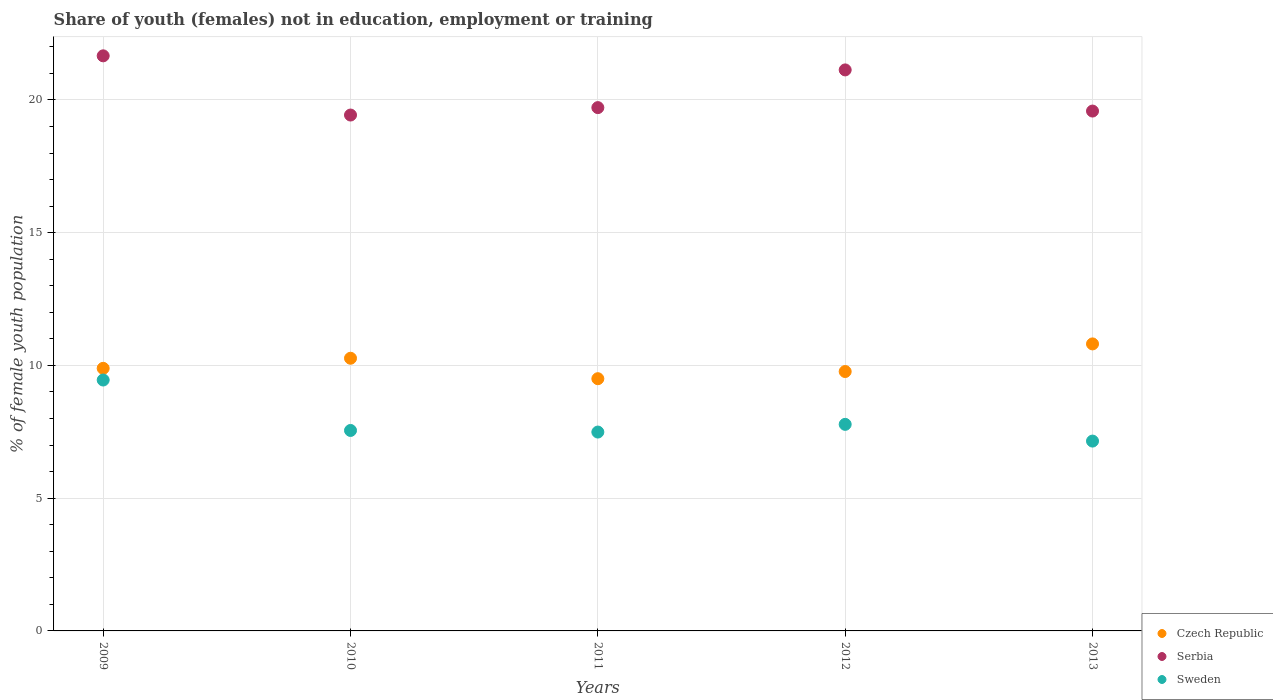What is the percentage of unemployed female population in in Czech Republic in 2009?
Provide a short and direct response. 9.89. Across all years, what is the maximum percentage of unemployed female population in in Serbia?
Make the answer very short. 21.66. Across all years, what is the minimum percentage of unemployed female population in in Czech Republic?
Provide a succinct answer. 9.5. What is the total percentage of unemployed female population in in Czech Republic in the graph?
Your response must be concise. 50.24. What is the difference between the percentage of unemployed female population in in Czech Republic in 2011 and that in 2013?
Offer a very short reply. -1.31. What is the difference between the percentage of unemployed female population in in Serbia in 2013 and the percentage of unemployed female population in in Czech Republic in 2012?
Your response must be concise. 9.81. What is the average percentage of unemployed female population in in Serbia per year?
Make the answer very short. 20.3. In the year 2009, what is the difference between the percentage of unemployed female population in in Serbia and percentage of unemployed female population in in Sweden?
Offer a terse response. 12.21. In how many years, is the percentage of unemployed female population in in Serbia greater than 1 %?
Ensure brevity in your answer.  5. What is the ratio of the percentage of unemployed female population in in Serbia in 2009 to that in 2011?
Ensure brevity in your answer.  1.1. What is the difference between the highest and the second highest percentage of unemployed female population in in Sweden?
Provide a short and direct response. 1.67. What is the difference between the highest and the lowest percentage of unemployed female population in in Serbia?
Keep it short and to the point. 2.23. In how many years, is the percentage of unemployed female population in in Czech Republic greater than the average percentage of unemployed female population in in Czech Republic taken over all years?
Your answer should be very brief. 2. Is the sum of the percentage of unemployed female population in in Czech Republic in 2009 and 2013 greater than the maximum percentage of unemployed female population in in Sweden across all years?
Make the answer very short. Yes. Is it the case that in every year, the sum of the percentage of unemployed female population in in Sweden and percentage of unemployed female population in in Czech Republic  is greater than the percentage of unemployed female population in in Serbia?
Your answer should be very brief. No. Does the percentage of unemployed female population in in Serbia monotonically increase over the years?
Give a very brief answer. No. How many years are there in the graph?
Your response must be concise. 5. Does the graph contain any zero values?
Ensure brevity in your answer.  No. Does the graph contain grids?
Keep it short and to the point. Yes. How many legend labels are there?
Keep it short and to the point. 3. How are the legend labels stacked?
Your answer should be compact. Vertical. What is the title of the graph?
Offer a very short reply. Share of youth (females) not in education, employment or training. Does "Burundi" appear as one of the legend labels in the graph?
Your answer should be very brief. No. What is the label or title of the Y-axis?
Offer a terse response. % of female youth population. What is the % of female youth population of Czech Republic in 2009?
Your answer should be compact. 9.89. What is the % of female youth population in Serbia in 2009?
Ensure brevity in your answer.  21.66. What is the % of female youth population of Sweden in 2009?
Keep it short and to the point. 9.45. What is the % of female youth population of Czech Republic in 2010?
Keep it short and to the point. 10.27. What is the % of female youth population in Serbia in 2010?
Your response must be concise. 19.43. What is the % of female youth population of Sweden in 2010?
Keep it short and to the point. 7.55. What is the % of female youth population of Serbia in 2011?
Your answer should be compact. 19.71. What is the % of female youth population in Sweden in 2011?
Your answer should be compact. 7.49. What is the % of female youth population of Czech Republic in 2012?
Offer a terse response. 9.77. What is the % of female youth population in Serbia in 2012?
Provide a succinct answer. 21.13. What is the % of female youth population of Sweden in 2012?
Your answer should be compact. 7.78. What is the % of female youth population of Czech Republic in 2013?
Make the answer very short. 10.81. What is the % of female youth population of Serbia in 2013?
Ensure brevity in your answer.  19.58. What is the % of female youth population in Sweden in 2013?
Make the answer very short. 7.15. Across all years, what is the maximum % of female youth population of Czech Republic?
Offer a very short reply. 10.81. Across all years, what is the maximum % of female youth population of Serbia?
Offer a very short reply. 21.66. Across all years, what is the maximum % of female youth population in Sweden?
Provide a succinct answer. 9.45. Across all years, what is the minimum % of female youth population of Czech Republic?
Offer a terse response. 9.5. Across all years, what is the minimum % of female youth population of Serbia?
Provide a short and direct response. 19.43. Across all years, what is the minimum % of female youth population in Sweden?
Your answer should be very brief. 7.15. What is the total % of female youth population in Czech Republic in the graph?
Give a very brief answer. 50.24. What is the total % of female youth population of Serbia in the graph?
Keep it short and to the point. 101.51. What is the total % of female youth population of Sweden in the graph?
Your answer should be compact. 39.42. What is the difference between the % of female youth population of Czech Republic in 2009 and that in 2010?
Offer a terse response. -0.38. What is the difference between the % of female youth population in Serbia in 2009 and that in 2010?
Provide a succinct answer. 2.23. What is the difference between the % of female youth population in Sweden in 2009 and that in 2010?
Offer a very short reply. 1.9. What is the difference between the % of female youth population in Czech Republic in 2009 and that in 2011?
Give a very brief answer. 0.39. What is the difference between the % of female youth population in Serbia in 2009 and that in 2011?
Make the answer very short. 1.95. What is the difference between the % of female youth population of Sweden in 2009 and that in 2011?
Your answer should be very brief. 1.96. What is the difference between the % of female youth population in Czech Republic in 2009 and that in 2012?
Make the answer very short. 0.12. What is the difference between the % of female youth population of Serbia in 2009 and that in 2012?
Offer a terse response. 0.53. What is the difference between the % of female youth population of Sweden in 2009 and that in 2012?
Give a very brief answer. 1.67. What is the difference between the % of female youth population in Czech Republic in 2009 and that in 2013?
Keep it short and to the point. -0.92. What is the difference between the % of female youth population in Serbia in 2009 and that in 2013?
Offer a terse response. 2.08. What is the difference between the % of female youth population of Sweden in 2009 and that in 2013?
Your response must be concise. 2.3. What is the difference between the % of female youth population in Czech Republic in 2010 and that in 2011?
Ensure brevity in your answer.  0.77. What is the difference between the % of female youth population of Serbia in 2010 and that in 2011?
Provide a short and direct response. -0.28. What is the difference between the % of female youth population in Sweden in 2010 and that in 2011?
Your answer should be very brief. 0.06. What is the difference between the % of female youth population of Czech Republic in 2010 and that in 2012?
Offer a terse response. 0.5. What is the difference between the % of female youth population of Serbia in 2010 and that in 2012?
Offer a very short reply. -1.7. What is the difference between the % of female youth population in Sweden in 2010 and that in 2012?
Your answer should be very brief. -0.23. What is the difference between the % of female youth population in Czech Republic in 2010 and that in 2013?
Give a very brief answer. -0.54. What is the difference between the % of female youth population of Serbia in 2010 and that in 2013?
Ensure brevity in your answer.  -0.15. What is the difference between the % of female youth population in Sweden in 2010 and that in 2013?
Make the answer very short. 0.4. What is the difference between the % of female youth population in Czech Republic in 2011 and that in 2012?
Your answer should be very brief. -0.27. What is the difference between the % of female youth population in Serbia in 2011 and that in 2012?
Ensure brevity in your answer.  -1.42. What is the difference between the % of female youth population in Sweden in 2011 and that in 2012?
Offer a terse response. -0.29. What is the difference between the % of female youth population in Czech Republic in 2011 and that in 2013?
Your answer should be compact. -1.31. What is the difference between the % of female youth population of Serbia in 2011 and that in 2013?
Ensure brevity in your answer.  0.13. What is the difference between the % of female youth population in Sweden in 2011 and that in 2013?
Offer a very short reply. 0.34. What is the difference between the % of female youth population of Czech Republic in 2012 and that in 2013?
Ensure brevity in your answer.  -1.04. What is the difference between the % of female youth population of Serbia in 2012 and that in 2013?
Offer a terse response. 1.55. What is the difference between the % of female youth population in Sweden in 2012 and that in 2013?
Offer a very short reply. 0.63. What is the difference between the % of female youth population in Czech Republic in 2009 and the % of female youth population in Serbia in 2010?
Provide a short and direct response. -9.54. What is the difference between the % of female youth population in Czech Republic in 2009 and the % of female youth population in Sweden in 2010?
Give a very brief answer. 2.34. What is the difference between the % of female youth population in Serbia in 2009 and the % of female youth population in Sweden in 2010?
Give a very brief answer. 14.11. What is the difference between the % of female youth population of Czech Republic in 2009 and the % of female youth population of Serbia in 2011?
Your response must be concise. -9.82. What is the difference between the % of female youth population of Serbia in 2009 and the % of female youth population of Sweden in 2011?
Provide a succinct answer. 14.17. What is the difference between the % of female youth population in Czech Republic in 2009 and the % of female youth population in Serbia in 2012?
Make the answer very short. -11.24. What is the difference between the % of female youth population in Czech Republic in 2009 and the % of female youth population in Sweden in 2012?
Make the answer very short. 2.11. What is the difference between the % of female youth population in Serbia in 2009 and the % of female youth population in Sweden in 2012?
Give a very brief answer. 13.88. What is the difference between the % of female youth population of Czech Republic in 2009 and the % of female youth population of Serbia in 2013?
Make the answer very short. -9.69. What is the difference between the % of female youth population of Czech Republic in 2009 and the % of female youth population of Sweden in 2013?
Keep it short and to the point. 2.74. What is the difference between the % of female youth population in Serbia in 2009 and the % of female youth population in Sweden in 2013?
Offer a very short reply. 14.51. What is the difference between the % of female youth population of Czech Republic in 2010 and the % of female youth population of Serbia in 2011?
Provide a short and direct response. -9.44. What is the difference between the % of female youth population in Czech Republic in 2010 and the % of female youth population in Sweden in 2011?
Your response must be concise. 2.78. What is the difference between the % of female youth population in Serbia in 2010 and the % of female youth population in Sweden in 2011?
Make the answer very short. 11.94. What is the difference between the % of female youth population in Czech Republic in 2010 and the % of female youth population in Serbia in 2012?
Give a very brief answer. -10.86. What is the difference between the % of female youth population in Czech Republic in 2010 and the % of female youth population in Sweden in 2012?
Your answer should be very brief. 2.49. What is the difference between the % of female youth population of Serbia in 2010 and the % of female youth population of Sweden in 2012?
Your answer should be very brief. 11.65. What is the difference between the % of female youth population in Czech Republic in 2010 and the % of female youth population in Serbia in 2013?
Your response must be concise. -9.31. What is the difference between the % of female youth population of Czech Republic in 2010 and the % of female youth population of Sweden in 2013?
Provide a short and direct response. 3.12. What is the difference between the % of female youth population of Serbia in 2010 and the % of female youth population of Sweden in 2013?
Keep it short and to the point. 12.28. What is the difference between the % of female youth population of Czech Republic in 2011 and the % of female youth population of Serbia in 2012?
Offer a very short reply. -11.63. What is the difference between the % of female youth population of Czech Republic in 2011 and the % of female youth population of Sweden in 2012?
Your answer should be very brief. 1.72. What is the difference between the % of female youth population of Serbia in 2011 and the % of female youth population of Sweden in 2012?
Offer a very short reply. 11.93. What is the difference between the % of female youth population of Czech Republic in 2011 and the % of female youth population of Serbia in 2013?
Ensure brevity in your answer.  -10.08. What is the difference between the % of female youth population of Czech Republic in 2011 and the % of female youth population of Sweden in 2013?
Offer a very short reply. 2.35. What is the difference between the % of female youth population in Serbia in 2011 and the % of female youth population in Sweden in 2013?
Ensure brevity in your answer.  12.56. What is the difference between the % of female youth population in Czech Republic in 2012 and the % of female youth population in Serbia in 2013?
Keep it short and to the point. -9.81. What is the difference between the % of female youth population in Czech Republic in 2012 and the % of female youth population in Sweden in 2013?
Ensure brevity in your answer.  2.62. What is the difference between the % of female youth population in Serbia in 2012 and the % of female youth population in Sweden in 2013?
Your answer should be very brief. 13.98. What is the average % of female youth population of Czech Republic per year?
Keep it short and to the point. 10.05. What is the average % of female youth population in Serbia per year?
Your response must be concise. 20.3. What is the average % of female youth population of Sweden per year?
Provide a succinct answer. 7.88. In the year 2009, what is the difference between the % of female youth population in Czech Republic and % of female youth population in Serbia?
Your answer should be very brief. -11.77. In the year 2009, what is the difference between the % of female youth population of Czech Republic and % of female youth population of Sweden?
Your response must be concise. 0.44. In the year 2009, what is the difference between the % of female youth population of Serbia and % of female youth population of Sweden?
Give a very brief answer. 12.21. In the year 2010, what is the difference between the % of female youth population in Czech Republic and % of female youth population in Serbia?
Offer a terse response. -9.16. In the year 2010, what is the difference between the % of female youth population of Czech Republic and % of female youth population of Sweden?
Your response must be concise. 2.72. In the year 2010, what is the difference between the % of female youth population in Serbia and % of female youth population in Sweden?
Your answer should be very brief. 11.88. In the year 2011, what is the difference between the % of female youth population in Czech Republic and % of female youth population in Serbia?
Make the answer very short. -10.21. In the year 2011, what is the difference between the % of female youth population of Czech Republic and % of female youth population of Sweden?
Make the answer very short. 2.01. In the year 2011, what is the difference between the % of female youth population in Serbia and % of female youth population in Sweden?
Keep it short and to the point. 12.22. In the year 2012, what is the difference between the % of female youth population of Czech Republic and % of female youth population of Serbia?
Ensure brevity in your answer.  -11.36. In the year 2012, what is the difference between the % of female youth population of Czech Republic and % of female youth population of Sweden?
Provide a short and direct response. 1.99. In the year 2012, what is the difference between the % of female youth population of Serbia and % of female youth population of Sweden?
Keep it short and to the point. 13.35. In the year 2013, what is the difference between the % of female youth population of Czech Republic and % of female youth population of Serbia?
Keep it short and to the point. -8.77. In the year 2013, what is the difference between the % of female youth population in Czech Republic and % of female youth population in Sweden?
Offer a very short reply. 3.66. In the year 2013, what is the difference between the % of female youth population of Serbia and % of female youth population of Sweden?
Keep it short and to the point. 12.43. What is the ratio of the % of female youth population of Serbia in 2009 to that in 2010?
Your answer should be very brief. 1.11. What is the ratio of the % of female youth population of Sweden in 2009 to that in 2010?
Ensure brevity in your answer.  1.25. What is the ratio of the % of female youth population of Czech Republic in 2009 to that in 2011?
Provide a short and direct response. 1.04. What is the ratio of the % of female youth population of Serbia in 2009 to that in 2011?
Keep it short and to the point. 1.1. What is the ratio of the % of female youth population of Sweden in 2009 to that in 2011?
Provide a short and direct response. 1.26. What is the ratio of the % of female youth population in Czech Republic in 2009 to that in 2012?
Your response must be concise. 1.01. What is the ratio of the % of female youth population in Serbia in 2009 to that in 2012?
Provide a short and direct response. 1.03. What is the ratio of the % of female youth population of Sweden in 2009 to that in 2012?
Your answer should be compact. 1.21. What is the ratio of the % of female youth population of Czech Republic in 2009 to that in 2013?
Provide a short and direct response. 0.91. What is the ratio of the % of female youth population in Serbia in 2009 to that in 2013?
Provide a succinct answer. 1.11. What is the ratio of the % of female youth population of Sweden in 2009 to that in 2013?
Your answer should be compact. 1.32. What is the ratio of the % of female youth population in Czech Republic in 2010 to that in 2011?
Keep it short and to the point. 1.08. What is the ratio of the % of female youth population in Serbia in 2010 to that in 2011?
Offer a very short reply. 0.99. What is the ratio of the % of female youth population in Sweden in 2010 to that in 2011?
Your answer should be compact. 1.01. What is the ratio of the % of female youth population of Czech Republic in 2010 to that in 2012?
Offer a terse response. 1.05. What is the ratio of the % of female youth population in Serbia in 2010 to that in 2012?
Your answer should be compact. 0.92. What is the ratio of the % of female youth population of Sweden in 2010 to that in 2012?
Provide a short and direct response. 0.97. What is the ratio of the % of female youth population in Czech Republic in 2010 to that in 2013?
Offer a very short reply. 0.95. What is the ratio of the % of female youth population of Serbia in 2010 to that in 2013?
Provide a succinct answer. 0.99. What is the ratio of the % of female youth population in Sweden in 2010 to that in 2013?
Make the answer very short. 1.06. What is the ratio of the % of female youth population in Czech Republic in 2011 to that in 2012?
Your answer should be very brief. 0.97. What is the ratio of the % of female youth population in Serbia in 2011 to that in 2012?
Provide a short and direct response. 0.93. What is the ratio of the % of female youth population in Sweden in 2011 to that in 2012?
Your answer should be compact. 0.96. What is the ratio of the % of female youth population of Czech Republic in 2011 to that in 2013?
Your response must be concise. 0.88. What is the ratio of the % of female youth population in Serbia in 2011 to that in 2013?
Your answer should be compact. 1.01. What is the ratio of the % of female youth population in Sweden in 2011 to that in 2013?
Give a very brief answer. 1.05. What is the ratio of the % of female youth population in Czech Republic in 2012 to that in 2013?
Offer a very short reply. 0.9. What is the ratio of the % of female youth population in Serbia in 2012 to that in 2013?
Provide a succinct answer. 1.08. What is the ratio of the % of female youth population of Sweden in 2012 to that in 2013?
Offer a very short reply. 1.09. What is the difference between the highest and the second highest % of female youth population of Czech Republic?
Your response must be concise. 0.54. What is the difference between the highest and the second highest % of female youth population of Serbia?
Offer a terse response. 0.53. What is the difference between the highest and the second highest % of female youth population in Sweden?
Provide a short and direct response. 1.67. What is the difference between the highest and the lowest % of female youth population of Czech Republic?
Your answer should be very brief. 1.31. What is the difference between the highest and the lowest % of female youth population in Serbia?
Your answer should be very brief. 2.23. 